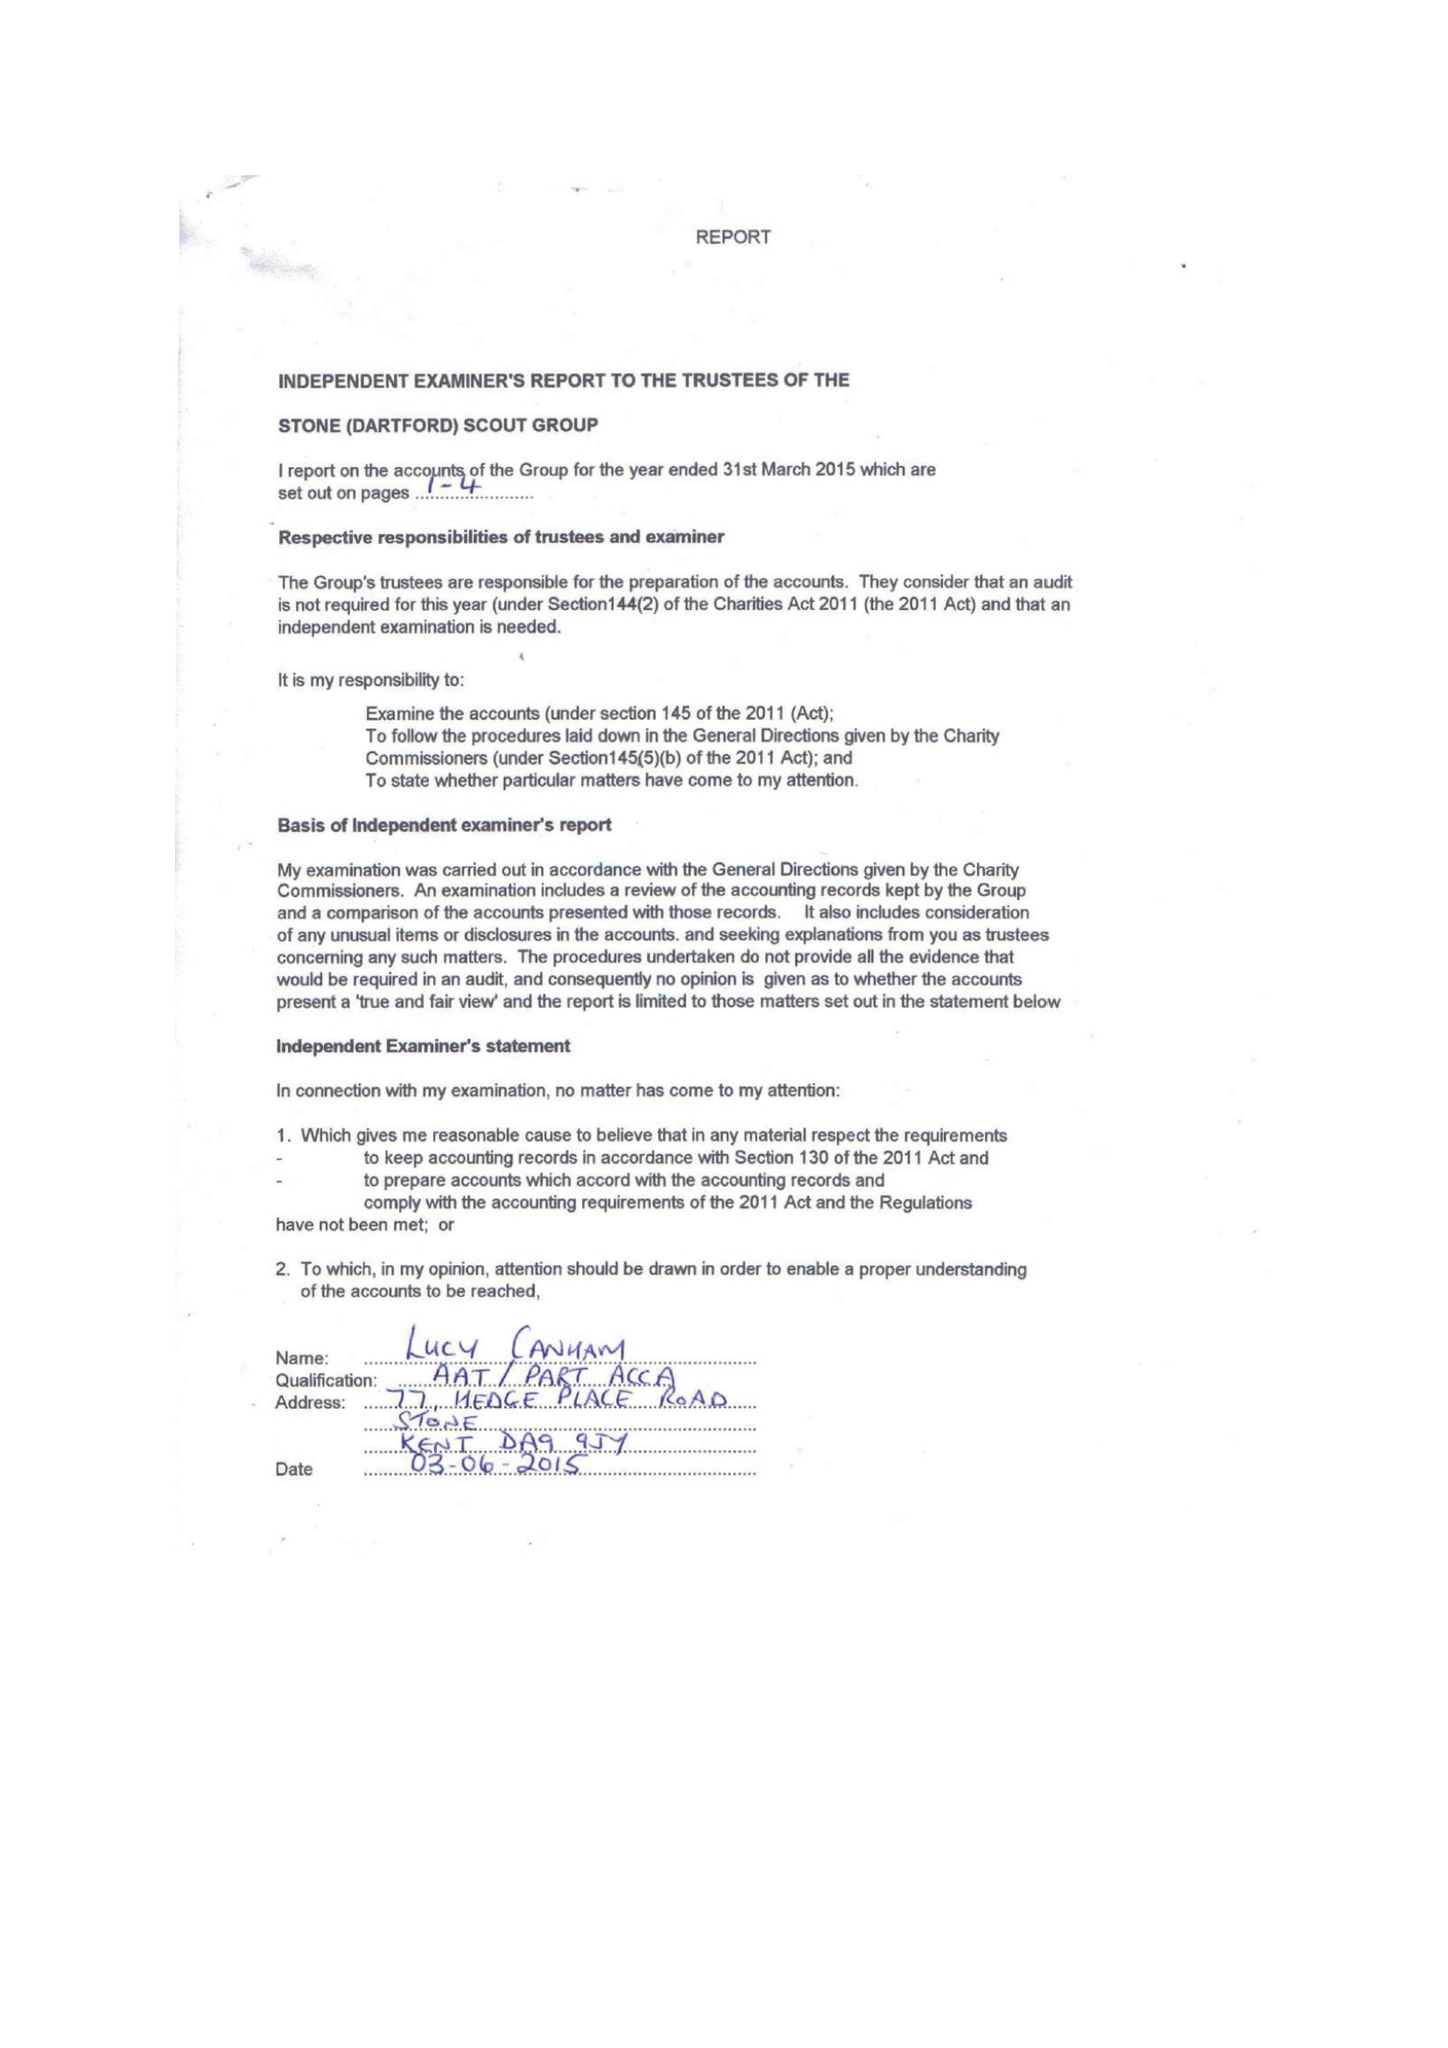What is the value for the address__post_town?
Answer the question using a single word or phrase. GREENHITHE 